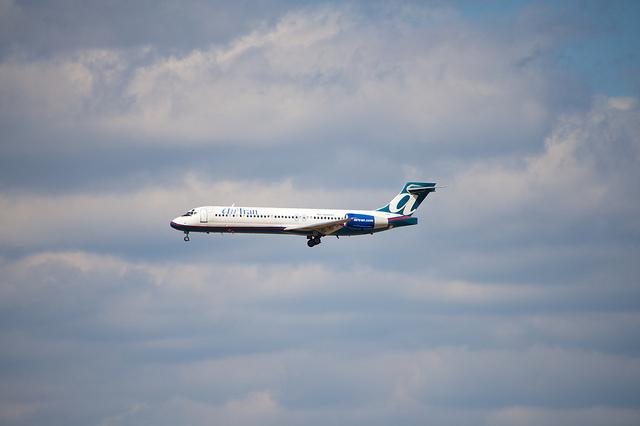What does the side of the plane say?
Short answer required. Airtran. Will this plane land soon?
Concise answer only. Yes. Is this a commercial airliner?
Give a very brief answer. Yes. What airliner is this?
Quick response, please. Airtran. What kind of cargo does this plane carry?
Be succinct. Passengers. How large is the jetliner flying in the clouds?
Answer briefly. Large. 